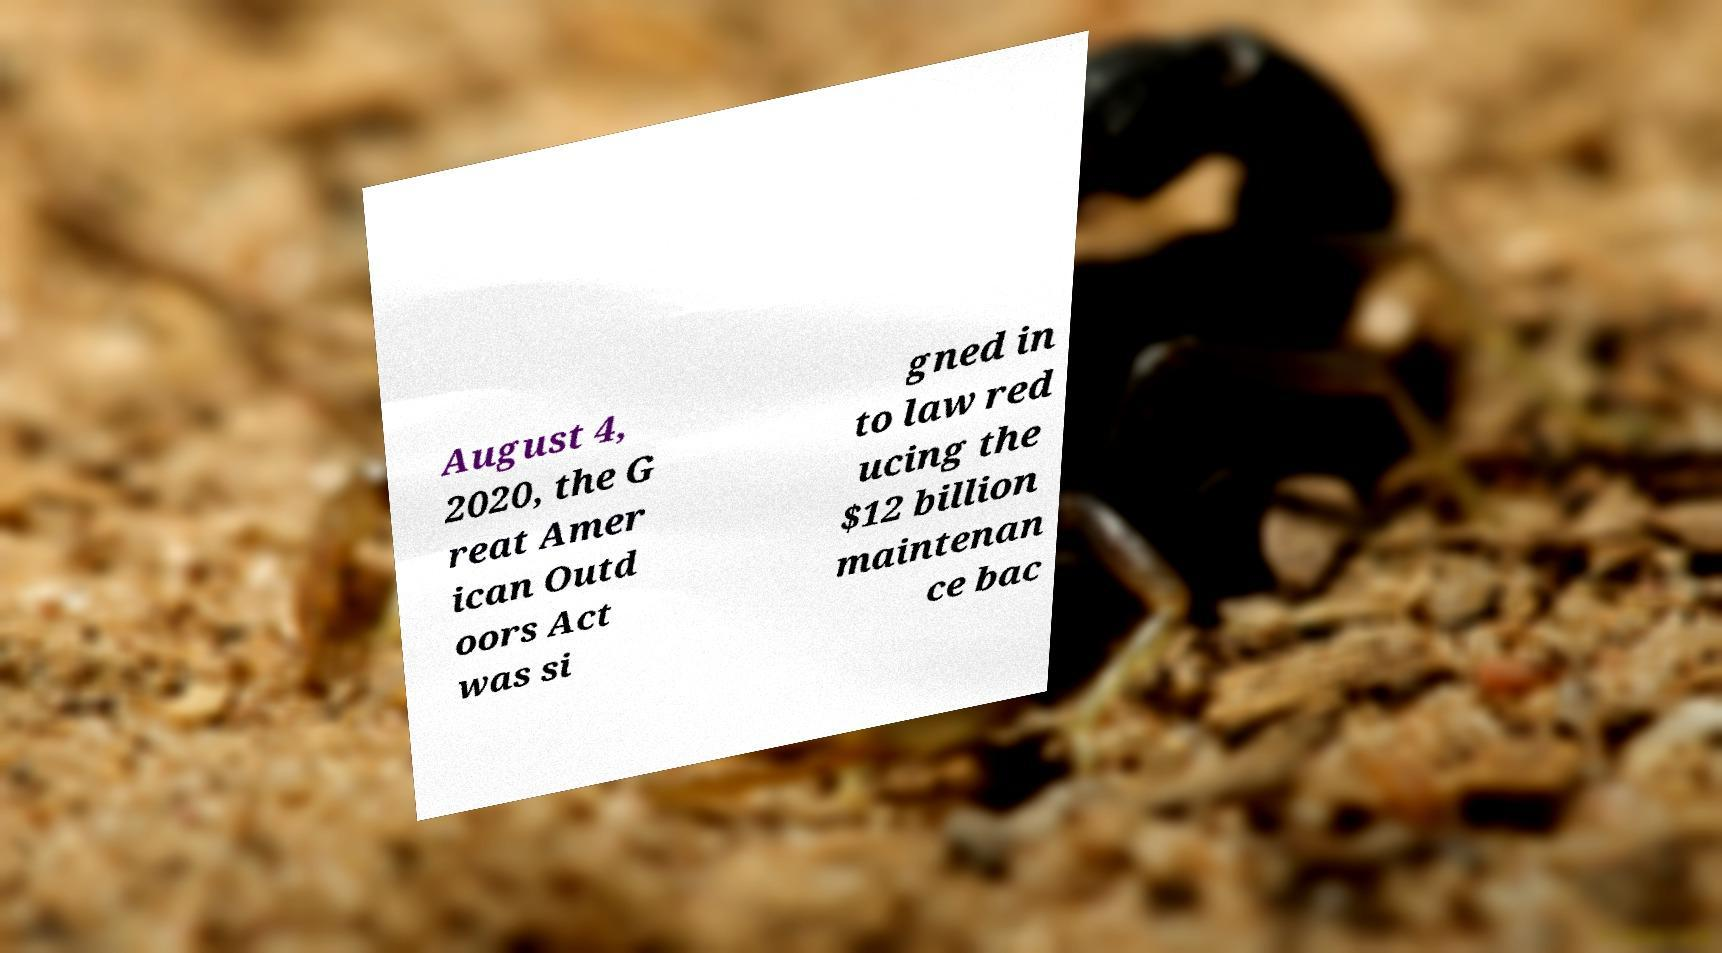Can you read and provide the text displayed in the image?This photo seems to have some interesting text. Can you extract and type it out for me? August 4, 2020, the G reat Amer ican Outd oors Act was si gned in to law red ucing the $12 billion maintenan ce bac 